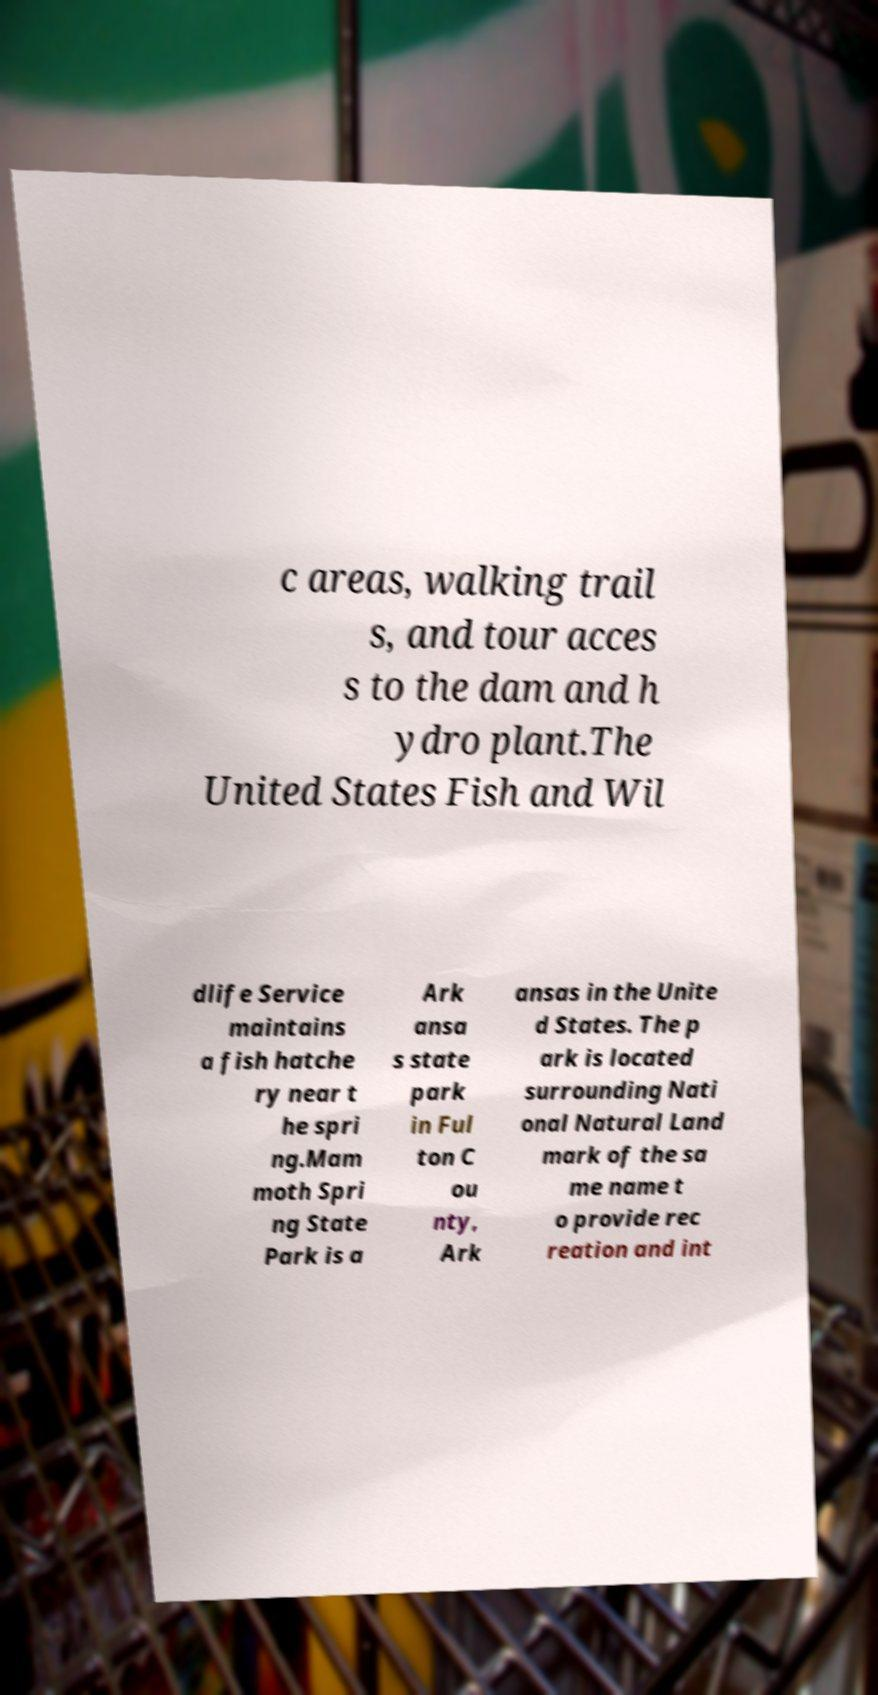There's text embedded in this image that I need extracted. Can you transcribe it verbatim? c areas, walking trail s, and tour acces s to the dam and h ydro plant.The United States Fish and Wil dlife Service maintains a fish hatche ry near t he spri ng.Mam moth Spri ng State Park is a Ark ansa s state park in Ful ton C ou nty, Ark ansas in the Unite d States. The p ark is located surrounding Nati onal Natural Land mark of the sa me name t o provide rec reation and int 